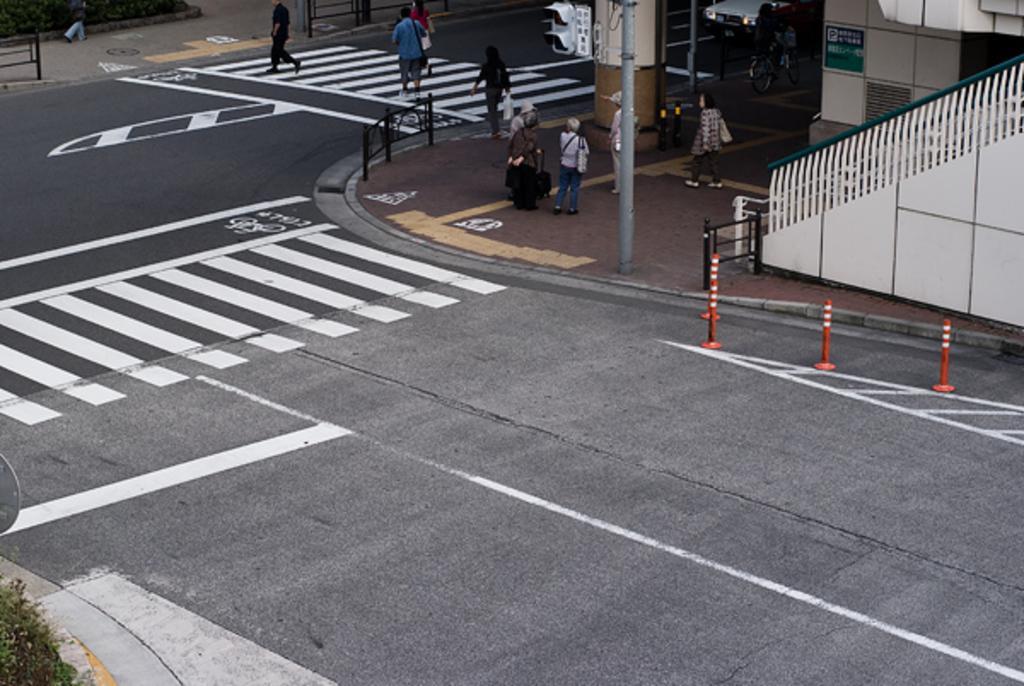In one or two sentences, can you explain what this image depicts? In this picture there is a road and there are few persons walking on zebra crossing and there is a pole which has traffic signals attached to it and there are few persons standing beside the pole and there is a staircase in the right corner. 